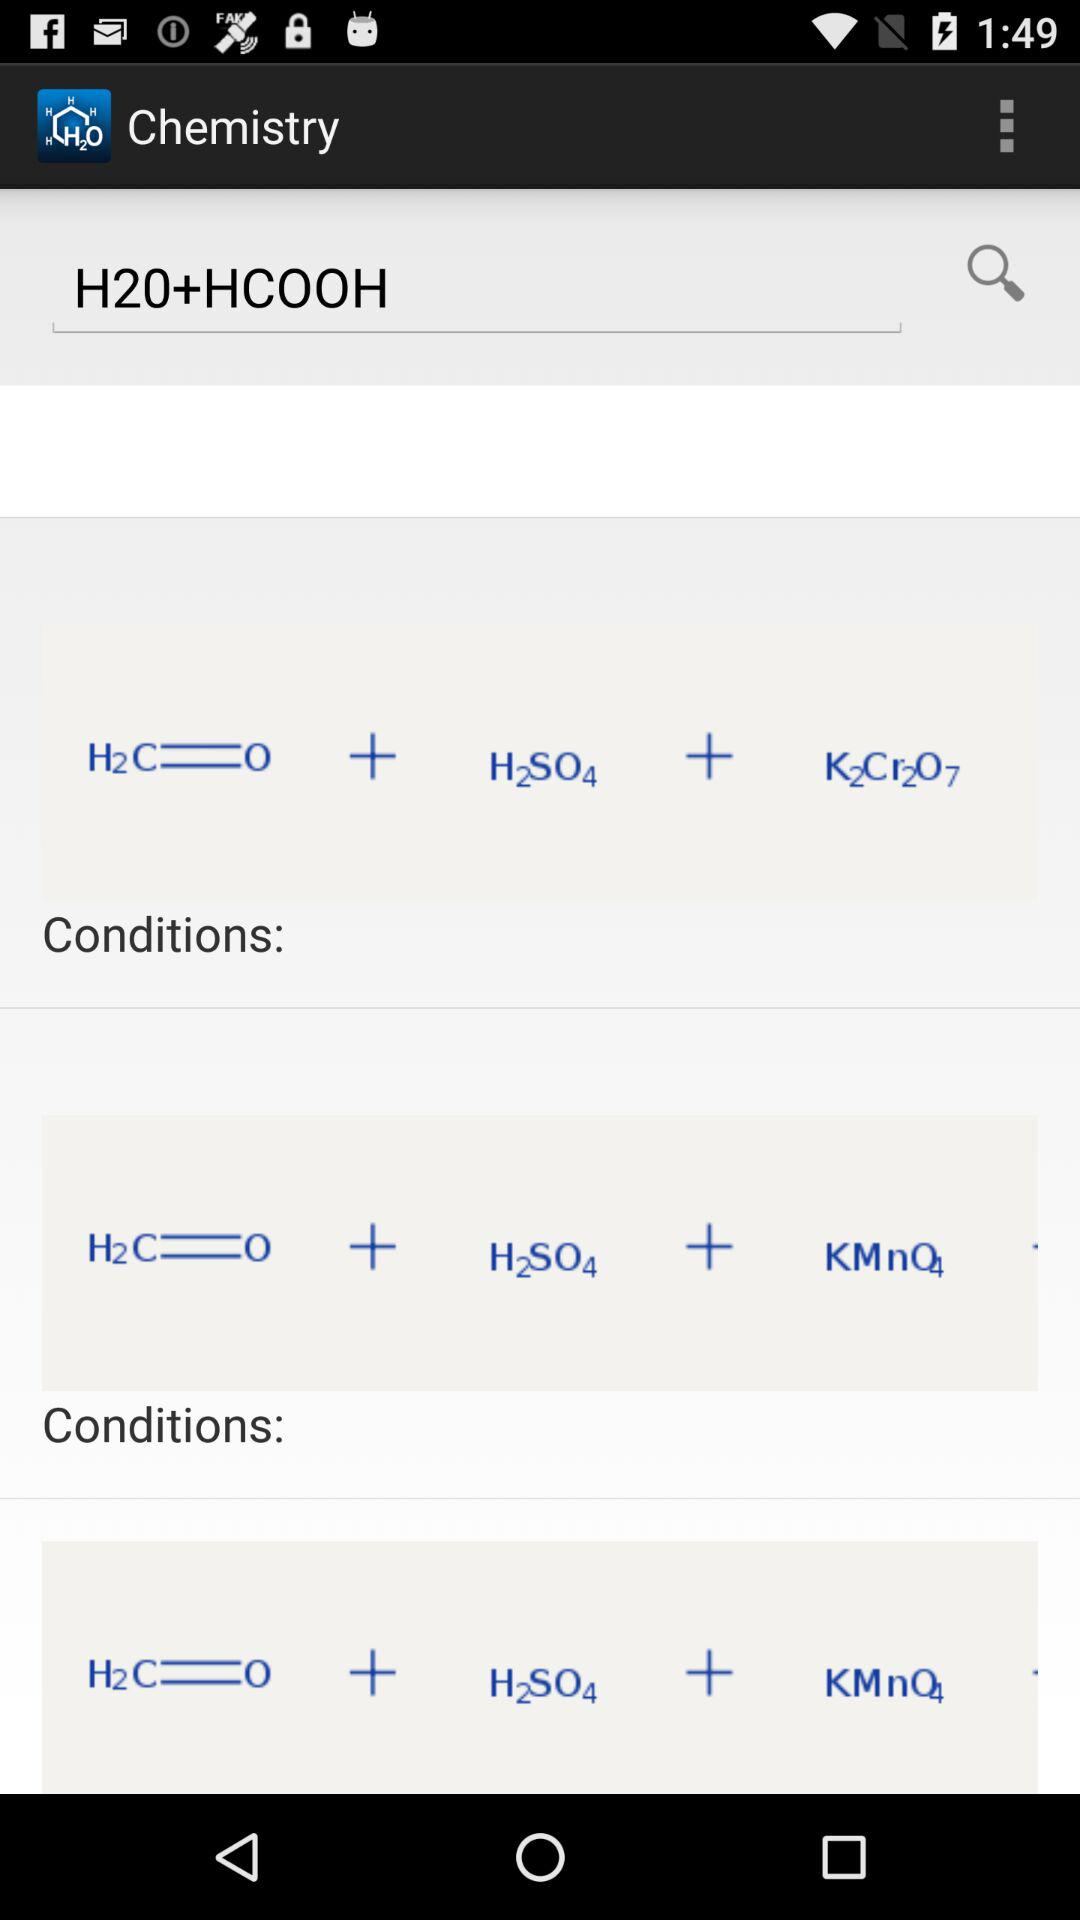Which compound is the chemical formula H2O?
When the provided information is insufficient, respond with <no answer>. <no answer> 